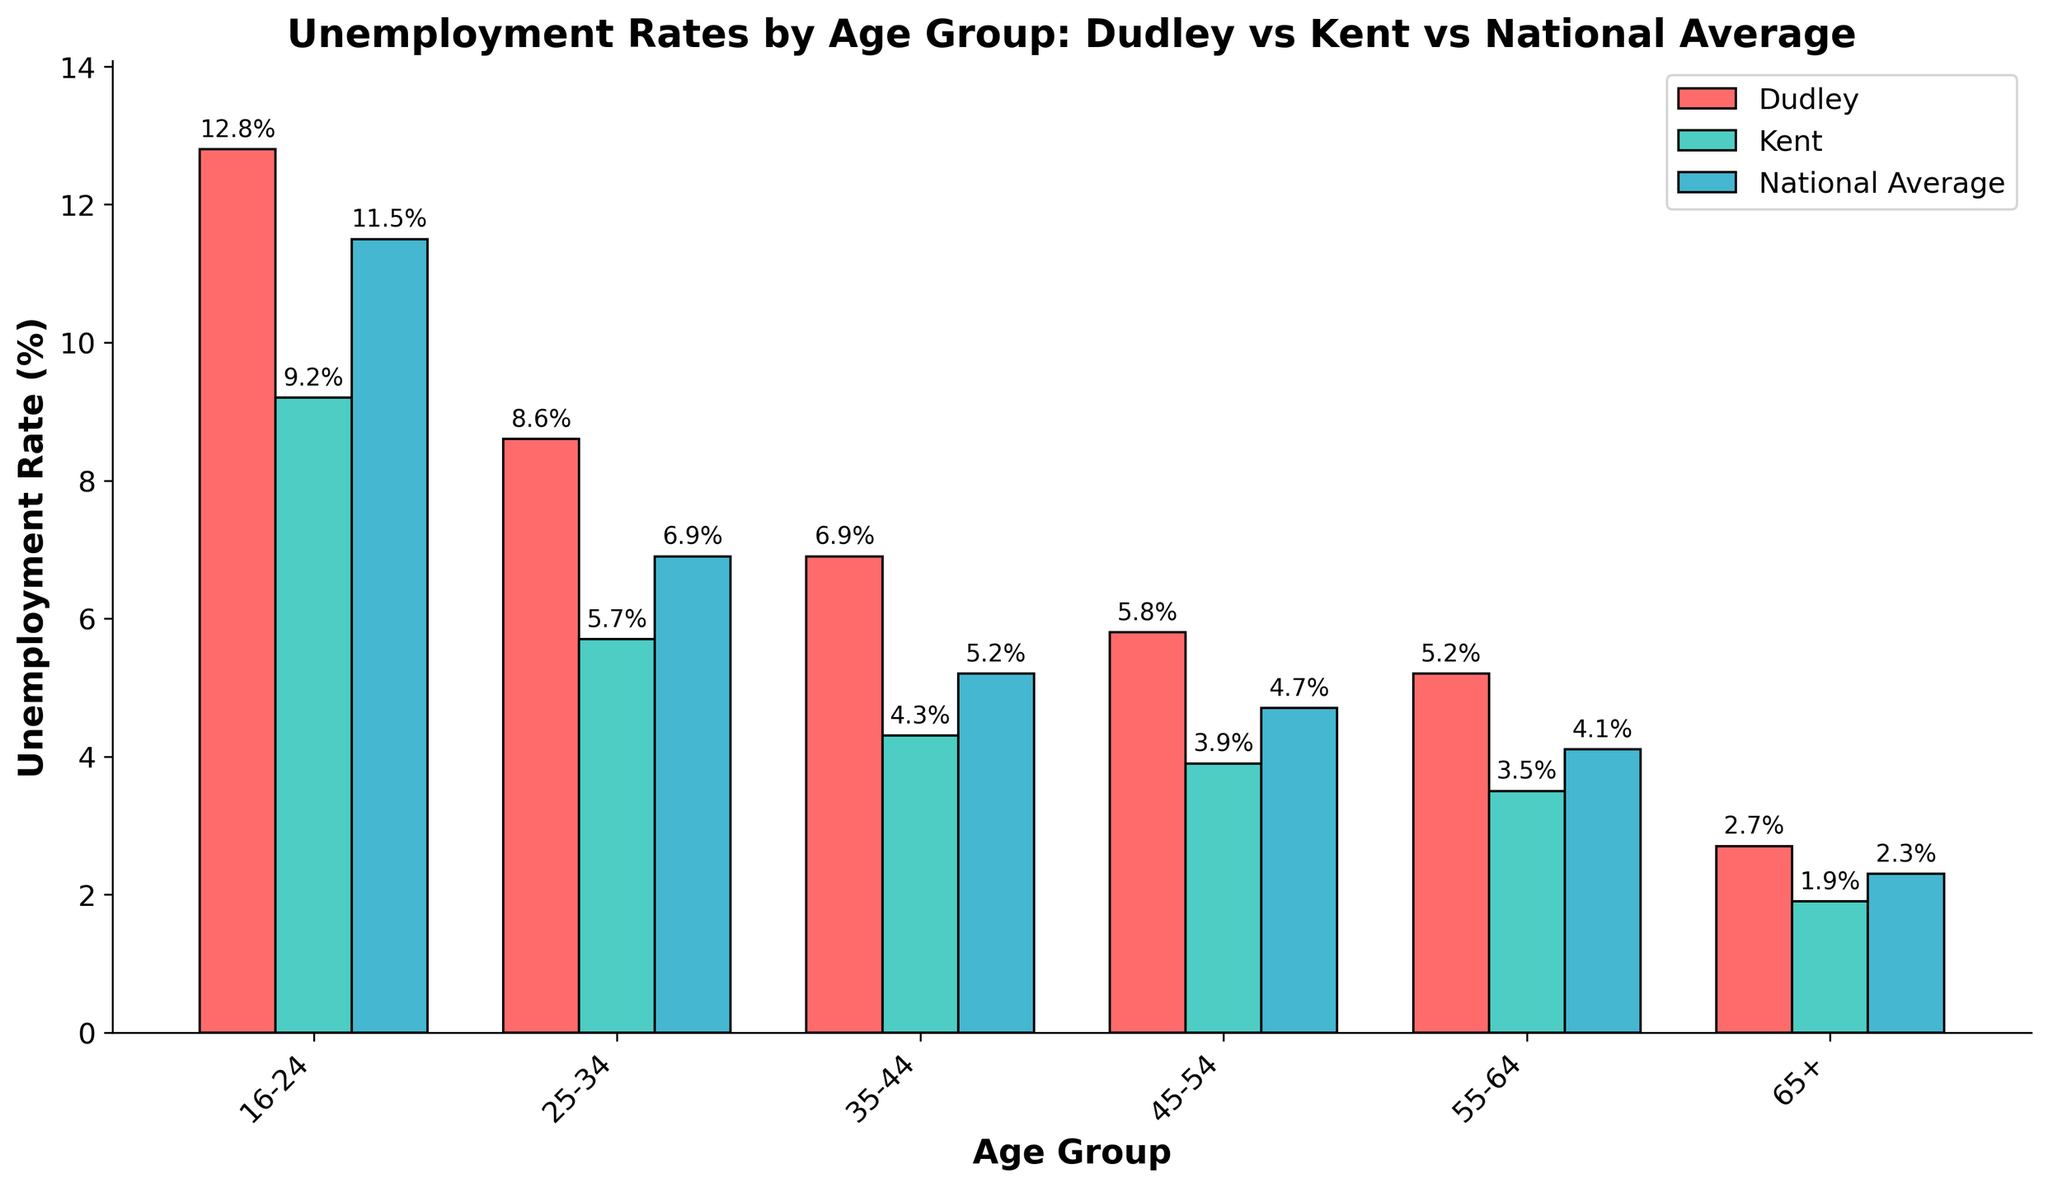What is the unemployment rate for the age group 16-24 in Dudley, Kent, and the national average? Look at the height of the bars labeled "16-24" for Dudley, Kent, and the National Average. Dudley is around 12.8%, Kent is around 9.2%, and the National Average is about 11.5%.
Answer: Dudley: 12.8%, Kent: 9.2%, National Average: 11.5% Which age group in Dudley has the highest unemployment rate? Examine the heights of the bars for Dudley across different age groups. The tallest bar for Dudley corresponds to the age group 16-24.
Answer: 16-24 How does the unemployment rate for the age group 25-34 in Dudley compare to Kent and the national average? Look at the bars for the age group labeled "25-34". Compare the height of the Dudley bar to those of Kent and the National Average. Dudley's bar is higher.
Answer: Dudley is higher What is the difference in the unemployment rate between Dudley and Kent for the age group 35-44? Note the heights of the bars for Dudley and Kent within the "35-44" category. Dudley's rate is 6.9%, and Kent's rate is 4.3%. Subtract the two rates: 6.9% - 4.3% = 2.6%.
Answer: 2.6% What is the average unemployment rate for Dudley across all age groups? Sum up all the unemployment rates for Dudley and then divide by the number of age groups. (12.8 + 8.6 + 6.9 + 5.8 + 5.2 + 2.7) / 6 = 41 / 6 = 6.83%.
Answer: 6.83% Which age group's unemployment rate in Kent is closest to the national average for the same age group? Compare the heights of Kent's bars to the corresponding National Average bars. For each age group, find the one where Kent's rate is closest to the National Average. For Kent: 9.2% (National: 11.5% for 16-24), 5.7% (National: 6.9% for 25-34), 4.3% (National: 5.2% for 35-44), 3.9% (National: 4.7% for 45-54), 3.5% (National: 4.1% for 55-64), 1.9% (National: 2.3% for 65+). The closest is Kent's 9.2% to National's 11.5% for 16-24.
Answer: 16-24 For which age group is the unemployment rate difference between Dudley and the National Average the smallest? Calculate the differences for each age group and find the smallest value. Differences are: 16-24 (1.3), 25-34 (1.7), 35-44 (1.7), 45-54 (1.1), 55-64 (1.1), 65+ (0.4). The smallest difference is for the 65+ age group.
Answer: 65+ Which color represents the unemployment rates in Dudley? Identify the color assigned to Dudley by looking at the legend in the figure. Dudley rates are represented by red bars.
Answer: Red Is there any age group where Dudley's unemployment rate is lower than both Kent and the national average? If so, which one? Compare the bars for each age group. For Dudley's rates to be lower, the red bar must be shorter than both the green (Kent) and blue (National Average) bars. No such age group exists as Dudley's rates are always higher.
Answer: None What can be inferred about the employment situation in Dudley compared to Kent and the national average based on the data? Dudley consistently has higher unemployment rates across all age groups compared to Kent and the national average. This indicates potential local economic challenges or other factors affecting employment in Dudley.
Answer: Dudley faces more unemployment issues 